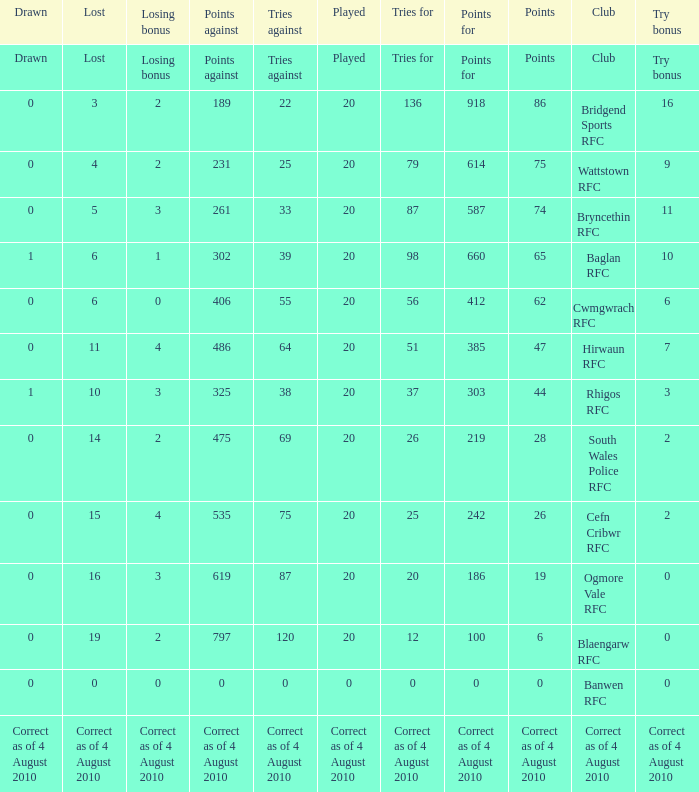What is lost when the points against is 231? 4.0. 